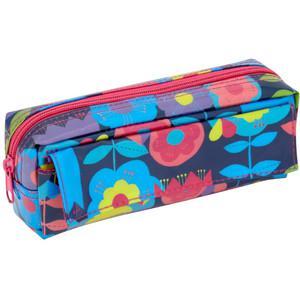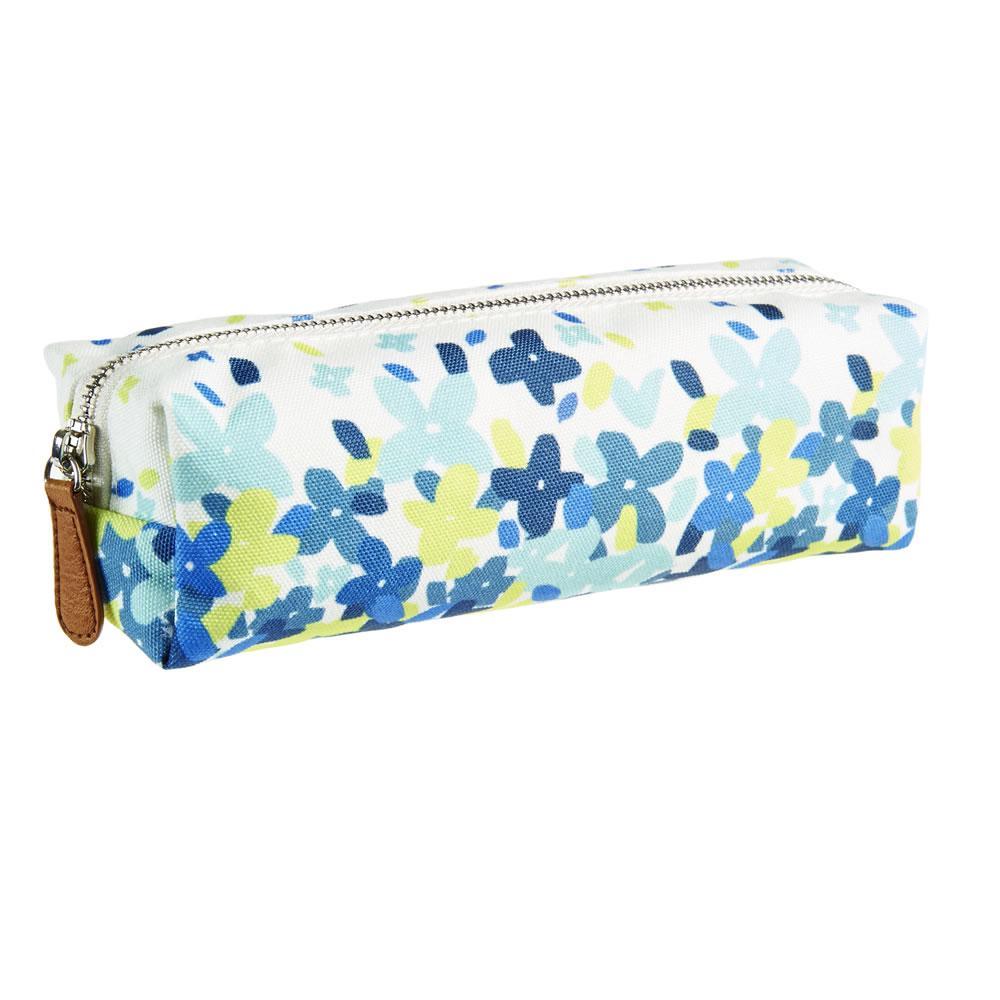The first image is the image on the left, the second image is the image on the right. Evaluate the accuracy of this statement regarding the images: "Left and right images each show one soft-sided tube-shaped zipper case displayed at the same angle.". Is it true? Answer yes or no. Yes. The first image is the image on the left, the second image is the image on the right. Evaluate the accuracy of this statement regarding the images: "There are two pencil cases and they both have a similar long shape.". Is it true? Answer yes or no. Yes. 